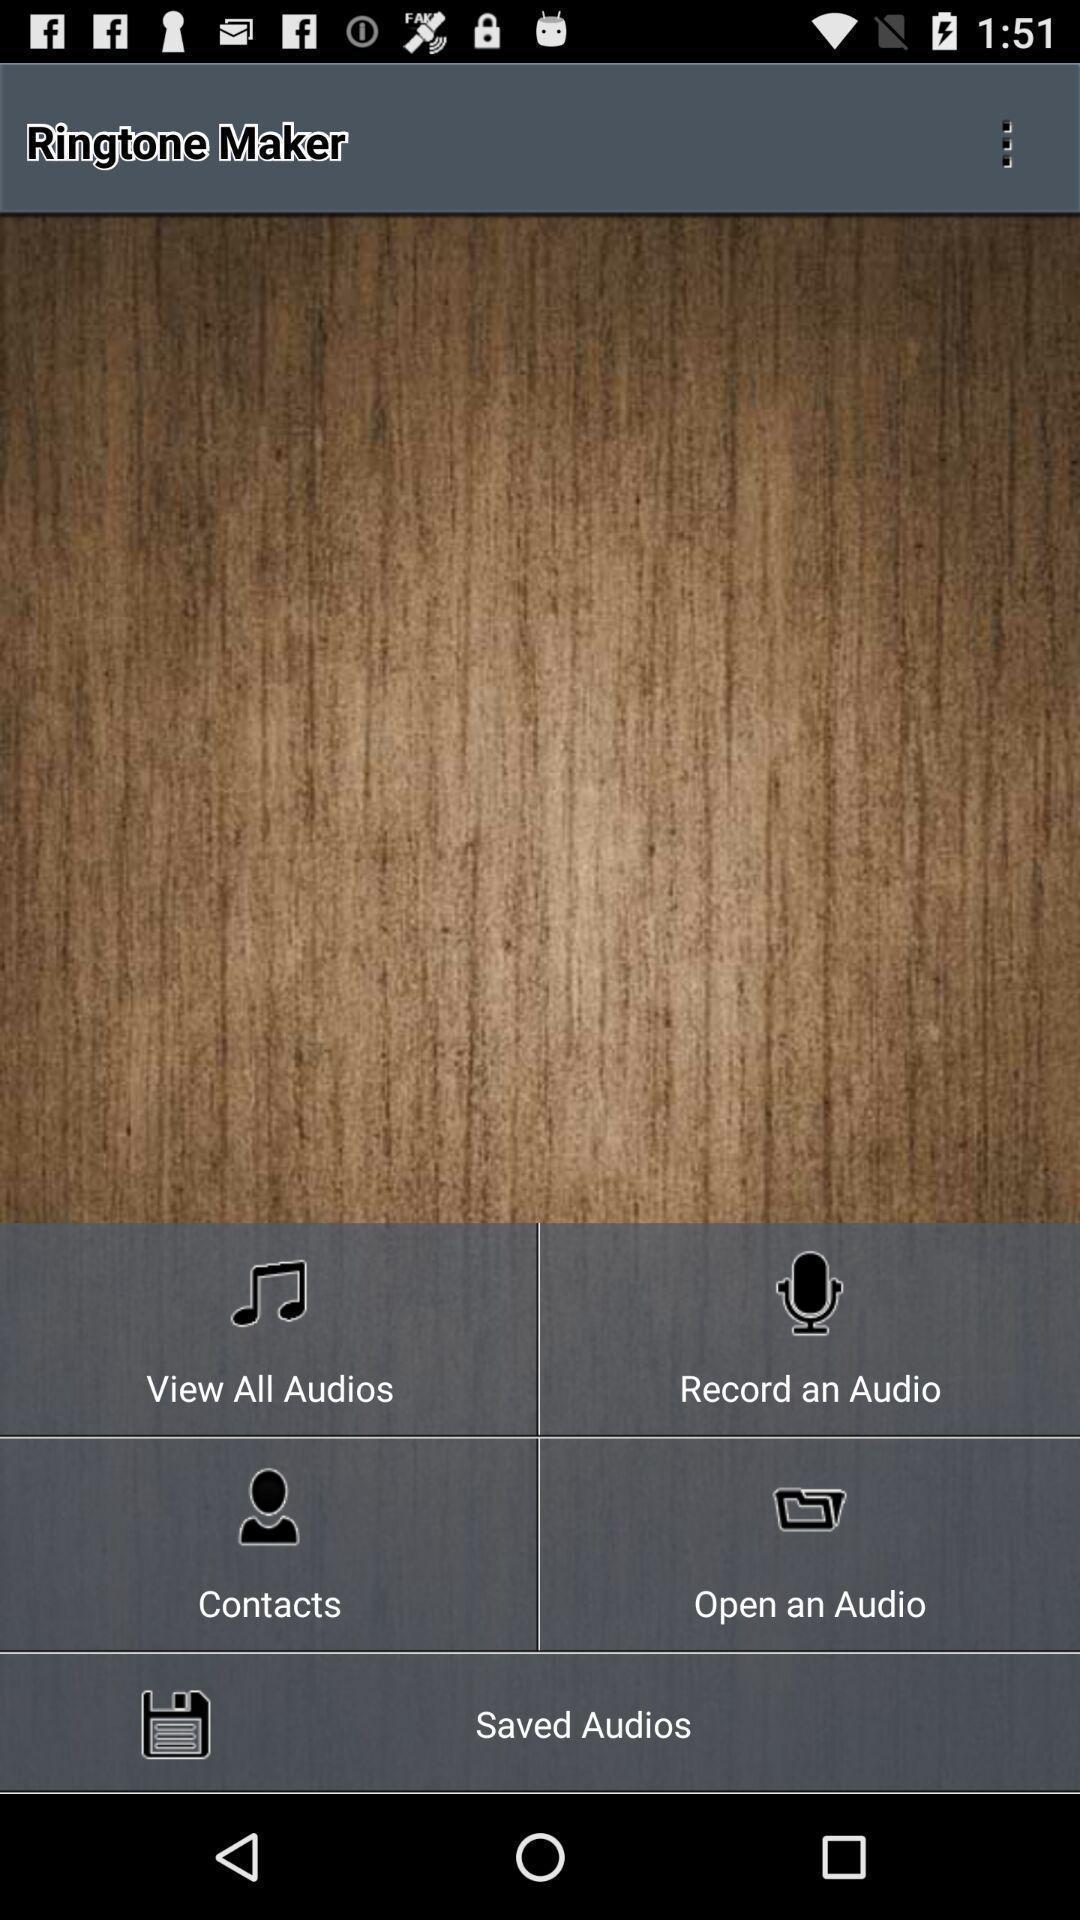Describe the key features of this screenshot. Page with different options for making ringtones. 